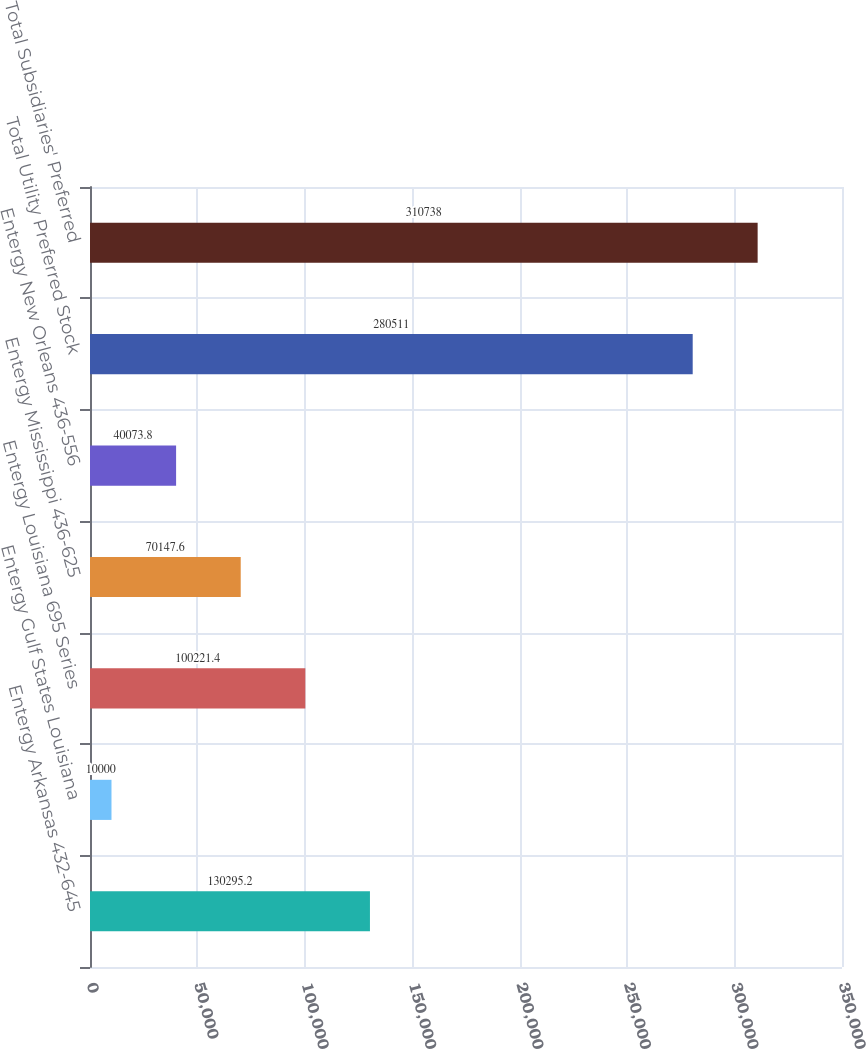Convert chart to OTSL. <chart><loc_0><loc_0><loc_500><loc_500><bar_chart><fcel>Entergy Arkansas 432-645<fcel>Entergy Gulf States Louisiana<fcel>Entergy Louisiana 695 Series<fcel>Entergy Mississippi 436-625<fcel>Entergy New Orleans 436-556<fcel>Total Utility Preferred Stock<fcel>Total Subsidiaries' Preferred<nl><fcel>130295<fcel>10000<fcel>100221<fcel>70147.6<fcel>40073.8<fcel>280511<fcel>310738<nl></chart> 